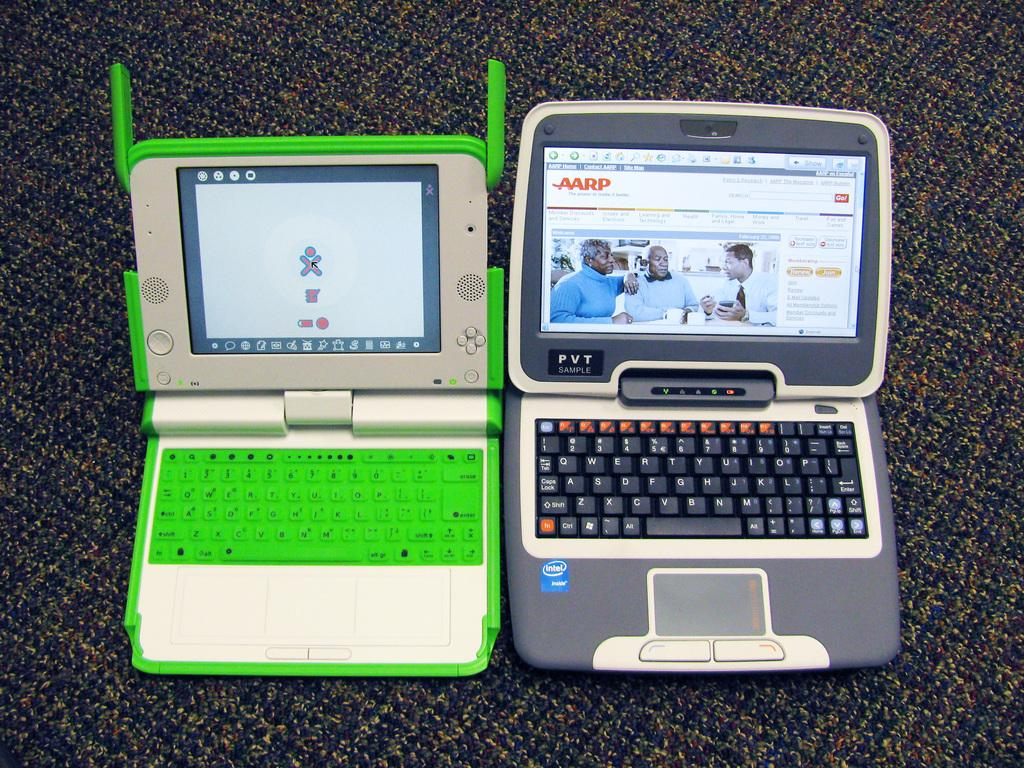<image>
Create a compact narrative representing the image presented. Lime green laptop next to a small black laptop with an intel sticker on it. 